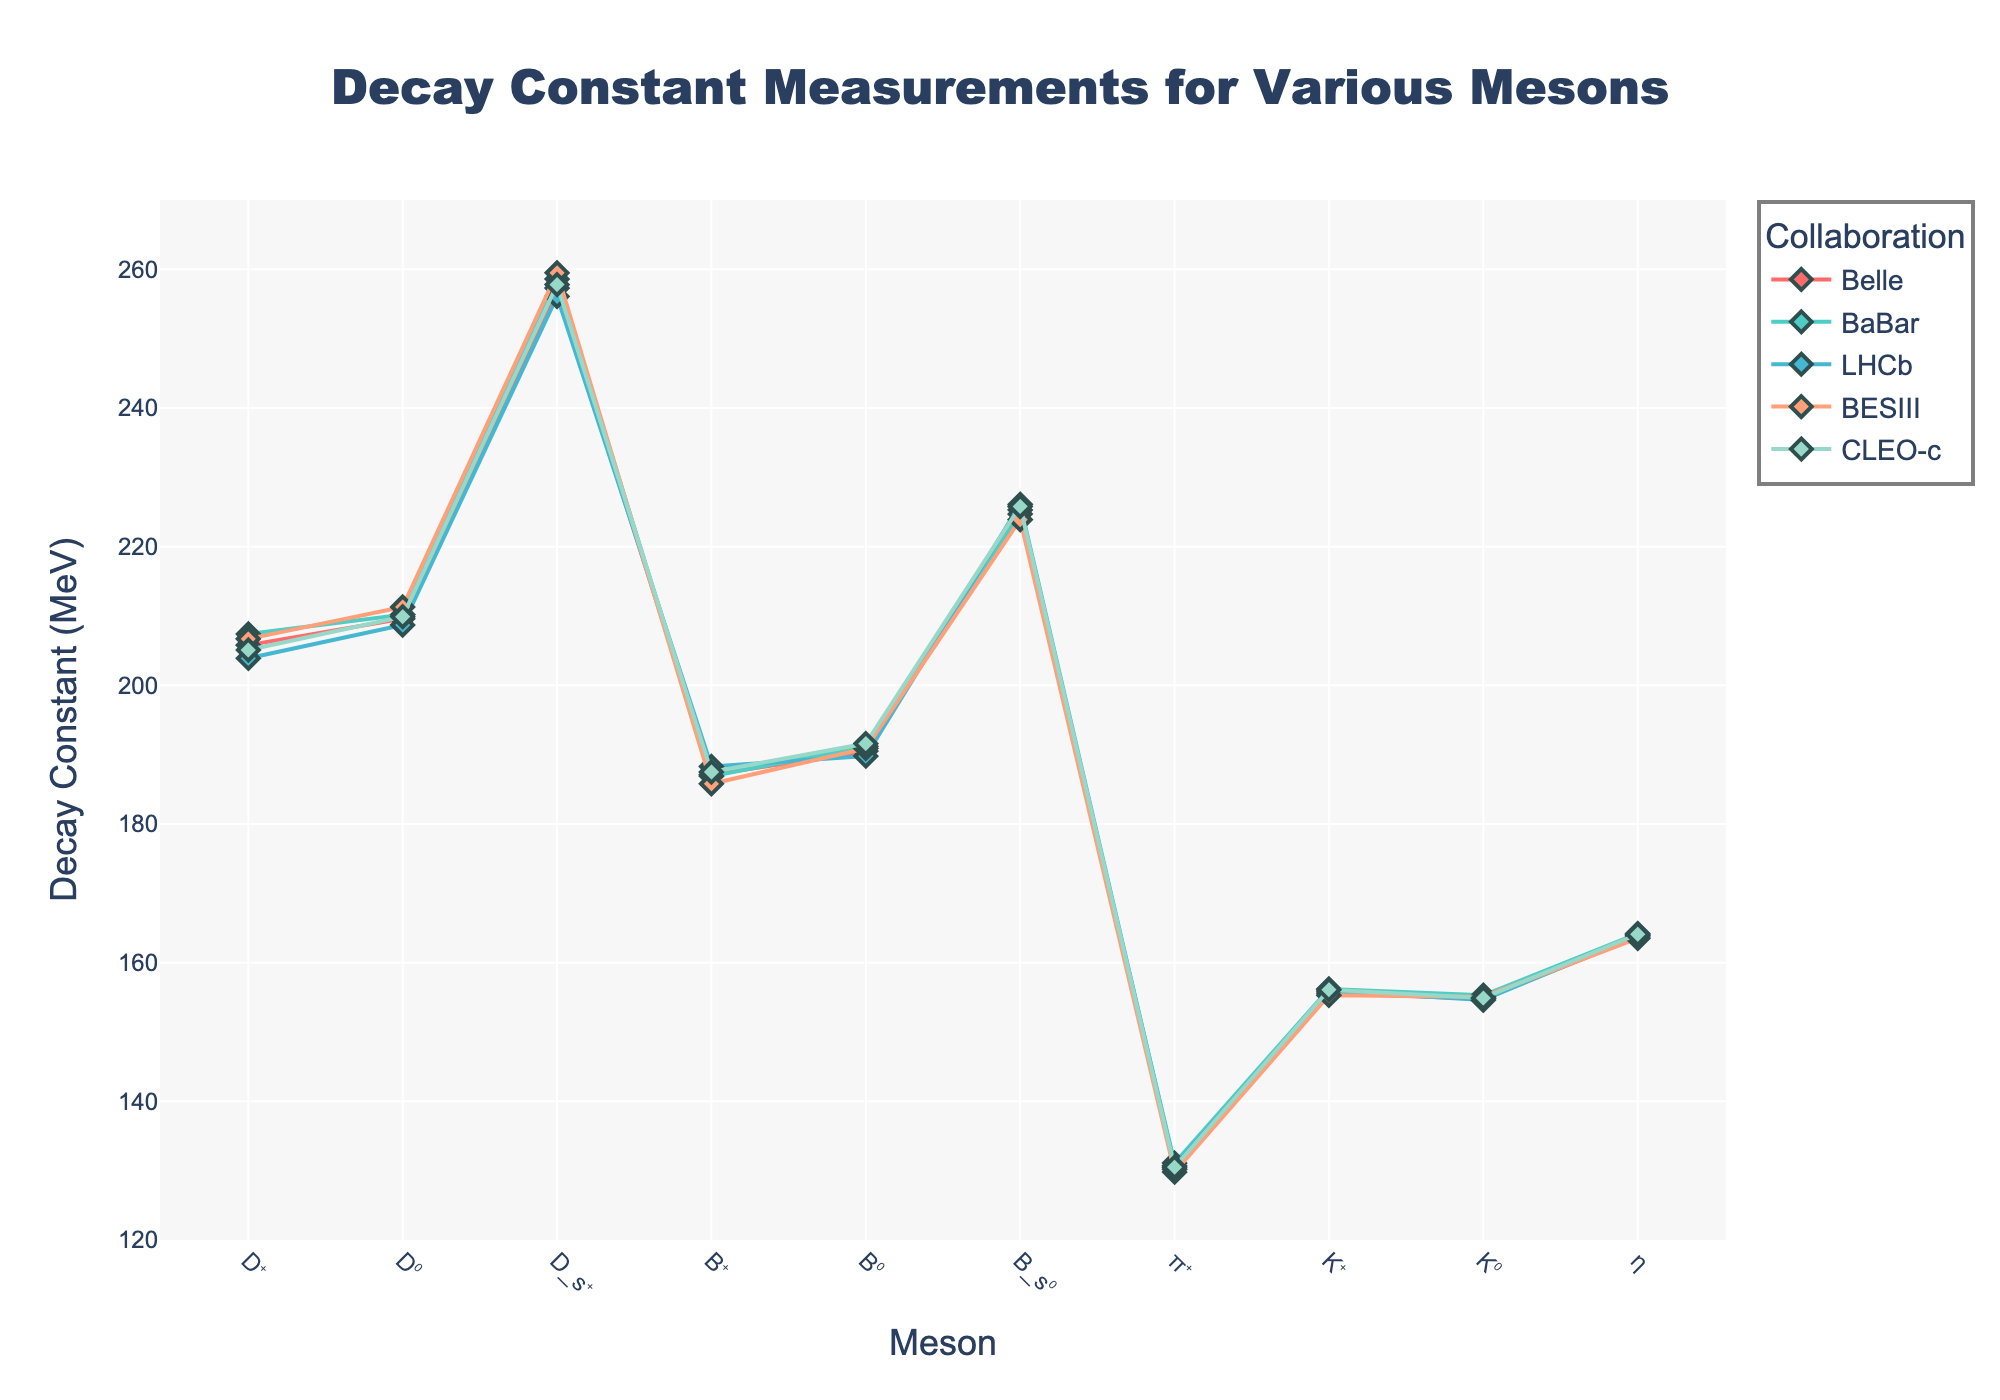What is the highest decay constant measured for the $D_s^+$ meson? To find the highest decay constant for the $D_s^+$ meson, look at all the values corresponding to it from the different collaborations. The values are 257.3 (Belle), 258.6 (BaBar), 256.1 (LHCb), 259.5 (BESIII), and 257.8 (CLEO-c). The highest among these is 259.5
Answer: 259.5 Which collaboration measured the lowest decay constant for the $B^+$ meson? To find the lowest decay constant for the $B^+$ meson, compare the values from each collaboration. They are 187.1 (Belle), 186.9 (BaBar), 188.3 (LHCb), 185.8 (BESIII), and 187.5 (CLEO-c). Therefore, the lowest value is from BESIII at 185.8
Answer: BESIII Is the decay constant of the $K^+$ meson greater than 155 MeV for all collaborations? To determine if the decay constant for the $K^+$ meson is greater than 155 MeV for all collaborations, check each measured value. They are 155.6 (Belle), 156.2 (BaBar), 155.9 (LHCb), 155.3 (BESIII), and 156.1 (CLEO-c). All of these values are above 155 MeV
Answer: Yes By how much does the decay constant measured for the $D^+$ meson by Belle differ from that measured by LHCb? Compare the decay constants for the $D^+$ meson by Belle and LHCb. Belle measured 205.8 MeV and LHCb measured 203.9 MeV. The difference is 205.8 - 203.9 = 1.9
Answer: 1.9 Which meson shows the greatest variation in decay constant measurements across different collaborations? To find this, calculate the range (maximum - minimum) of decay constants for each meson across the collaborations. The mesons and their ranges are: $D^+$ (207.4 - 203.9 = 3.5), $D^0$ (211.3 - 208.7 = 2.6), $D_s^+$ (259.5 - 256.1 = 3.4), $B^+$ (188.3 - 185.8 = 2.5), $B^0$ (191.6 - 189.8 = 1.8), $B_s^0$ (226.1 - 223.9 = 2.2), $π^+$ (131.1 - 129.8 = 1.3), $K^+$ (156.2 - 155.3 = 0.9), $K^0$ (155.3 - 154.6 = 0.7), and $η$ (164.2 - 163.5 = 0.7). The greatest variation is for the $D^+$ meson at 3.5
Answer: $D^+$ What is the average decay constant of the $\pi^+$ meson across all collaborations? To find the average, add the decay constants for the $\pi^+$ meson and divide by the number of collaborations. The values are 130.2, 131.1, 130.7, 129.8, and 130.5. Sum them up: 130.2 + 131.1 + 130.7 + 129.8 + 130.5 = 652.3. Divide by 5: 652.3 / 5 = 130.46
Answer: 130.46 For the $B_s^0$ meson, which collaboration reported the second highest decay constant? The decay constants for the $B_s^0$ meson are: 225.3 (Belle), 224.7 (BaBar), 226.1 (LHCb), 223.9 (BESIII), and 225.8 (CLEO-c). Sorted in descending order, they are 226.1 (LHCb), 225.8 (CLEO-c), 225.3 (Belle), 224.7 (BaBar), and 223.9 (BESIII). The second highest is 225.8 reported by CLEO-c
Answer: CLEO-c Between the Bell and BaBar measurements, which collaboration tends to report higher decay constants for the $K^0$ meson? Compare the decay constants for the $K^0$ meson: Belle reports 154.8 and BaBar reports 155.3. BaBar's measurement is higher
Answer: BaBar What is the mean difference in the decay constants of the $B^0$ meson compared to the $D^0$ meson across all collaborations? To find the mean difference: First, calculate the difference for each collaboration: Belle (190.5 - 209.6 = -19.1), BaBar (191.2 - 210.2 = -19), LHCb (189.8 - 208.7 = -18.9), BESIII (190.9 - 211.3 = -20.4), CLEO-c (191.6 - 209.9 = -18.3). Then, compute the average of these differences: (-19.1 - 19 - 18.9 - 20.4 - 18.3) / 5 = -19.14. Finally, the mean difference is 19.14
Answer: 19.14 